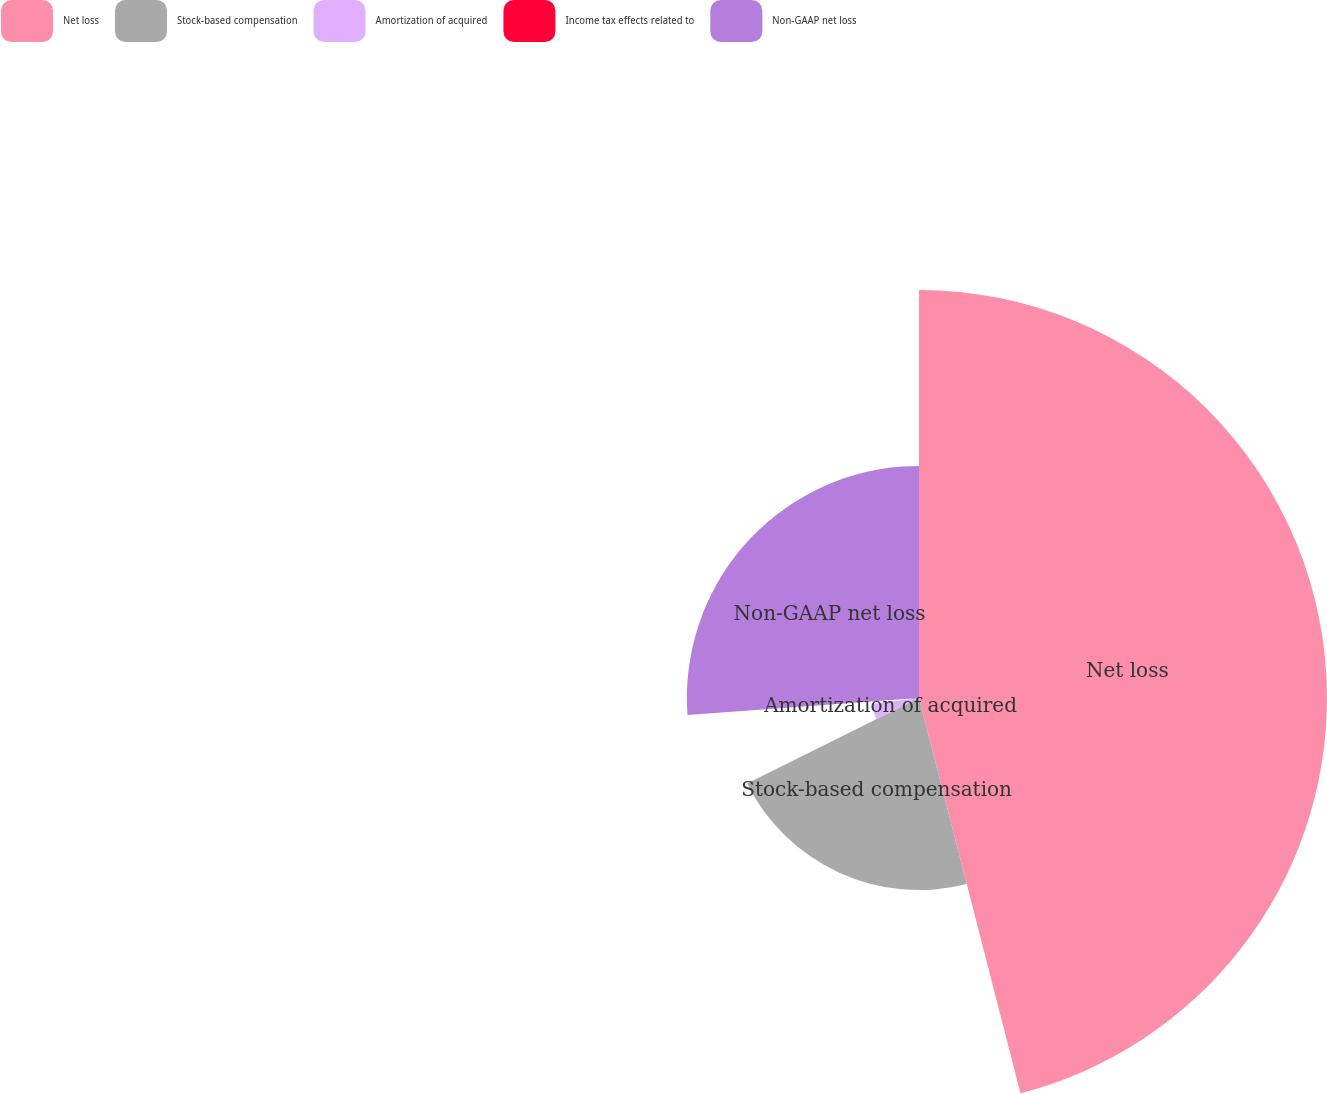Convert chart. <chart><loc_0><loc_0><loc_500><loc_500><pie_chart><fcel>Net loss<fcel>Stock-based compensation<fcel>Amortization of acquired<fcel>Income tax effects related to<fcel>Non-GAAP net loss<nl><fcel>46.0%<fcel>21.65%<fcel>5.35%<fcel>0.83%<fcel>26.17%<nl></chart> 